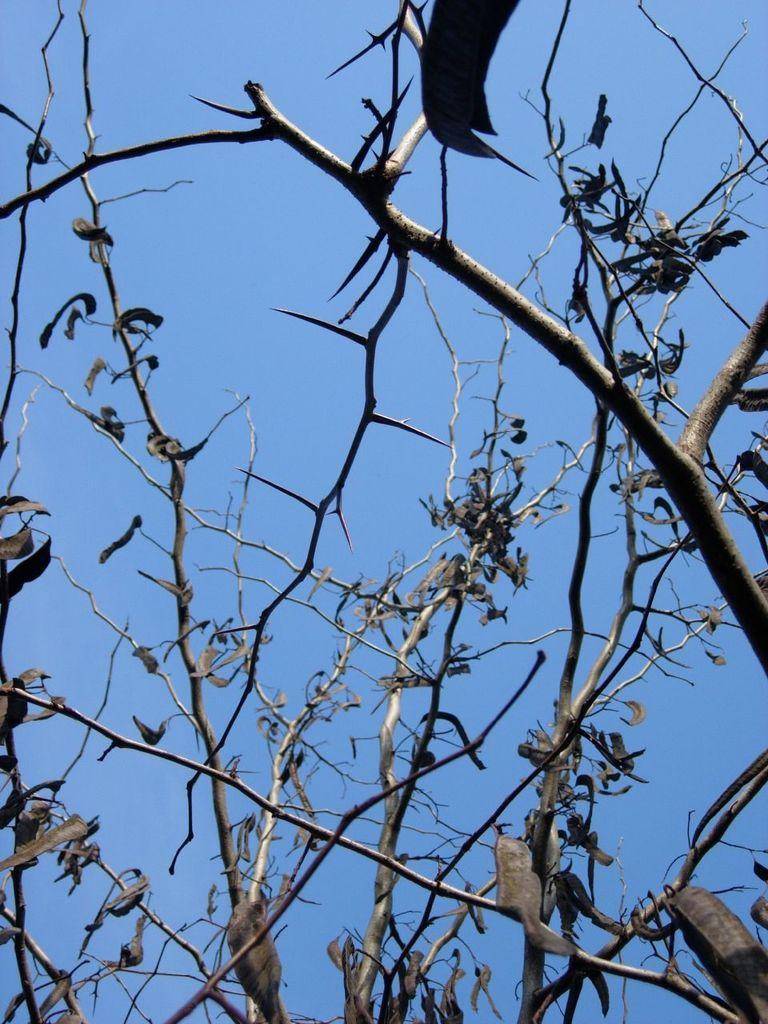Can you describe this image briefly? In this image we can see group of leaves and branches of a tree. In the background we can see the sky. 